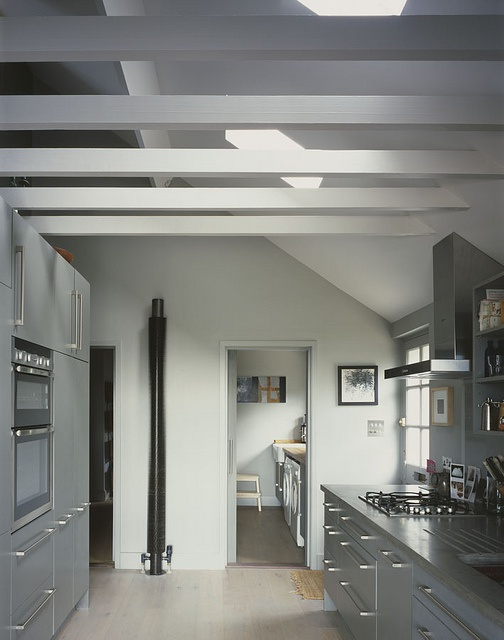Describe the objects in this image and their specific colors. I can see oven in gray and black tones, oven in gray, black, lightgray, and darkgray tones, chair in gray, darkgray, lightgray, and beige tones, sink in gray, lightgray, darkgray, and tan tones, and bottle in gray, black, and purple tones in this image. 